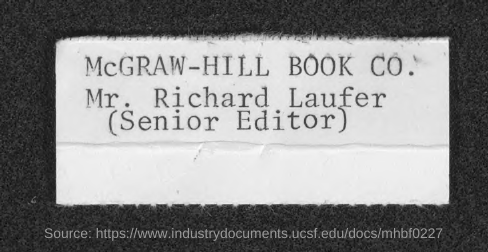List a handful of essential elements in this visual. Mr. Richard Laufer is the Senior Editor of McGraw-Hill Book Co. 